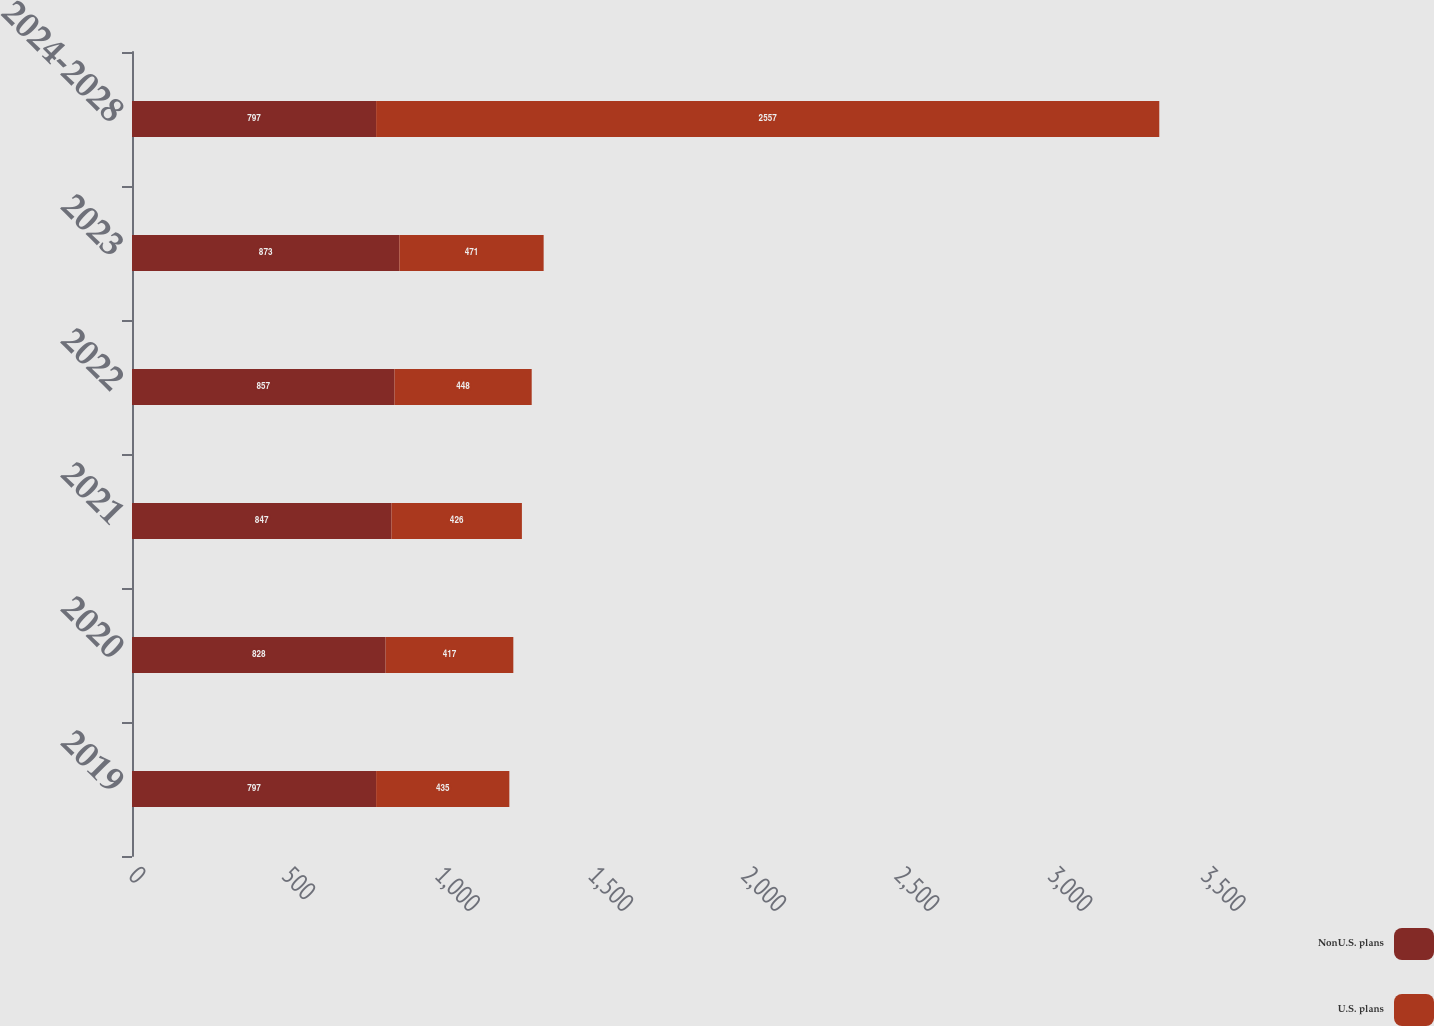<chart> <loc_0><loc_0><loc_500><loc_500><stacked_bar_chart><ecel><fcel>2019<fcel>2020<fcel>2021<fcel>2022<fcel>2023<fcel>2024-2028<nl><fcel>NonU.S. plans<fcel>797<fcel>828<fcel>847<fcel>857<fcel>873<fcel>797<nl><fcel>U.S. plans<fcel>435<fcel>417<fcel>426<fcel>448<fcel>471<fcel>2557<nl></chart> 